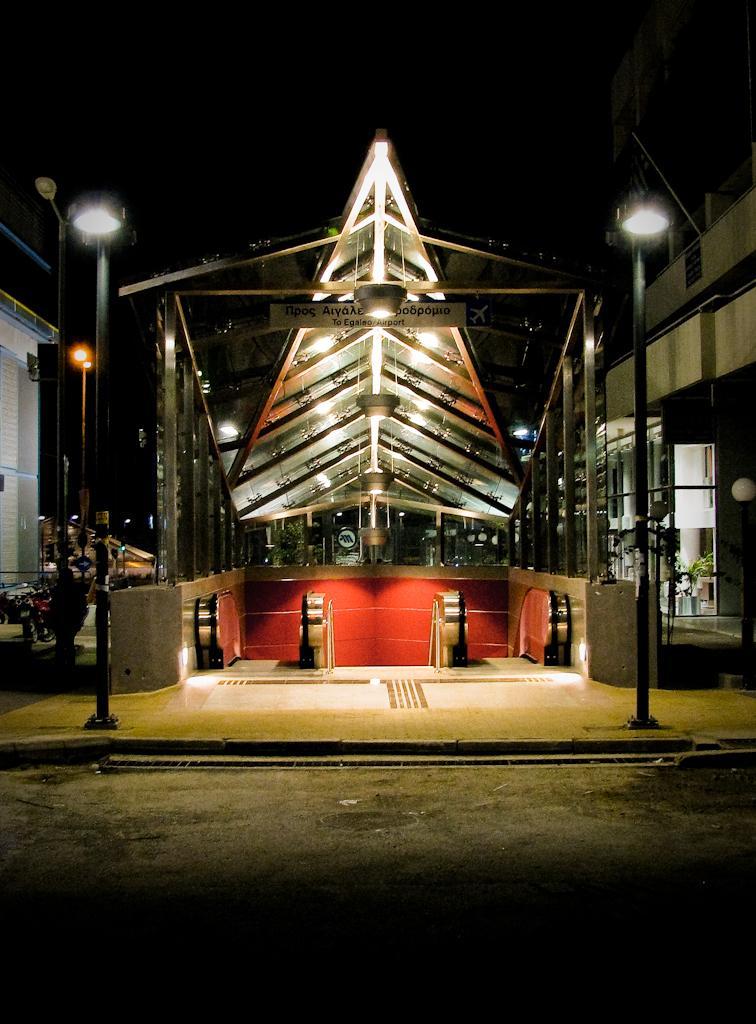Could you give a brief overview of what you see in this image? In the image there are two escalators in the tunnel, on either side of it there are street light on the road followed by buildings on either side of the image and behind it seems to be a wooden construction. 